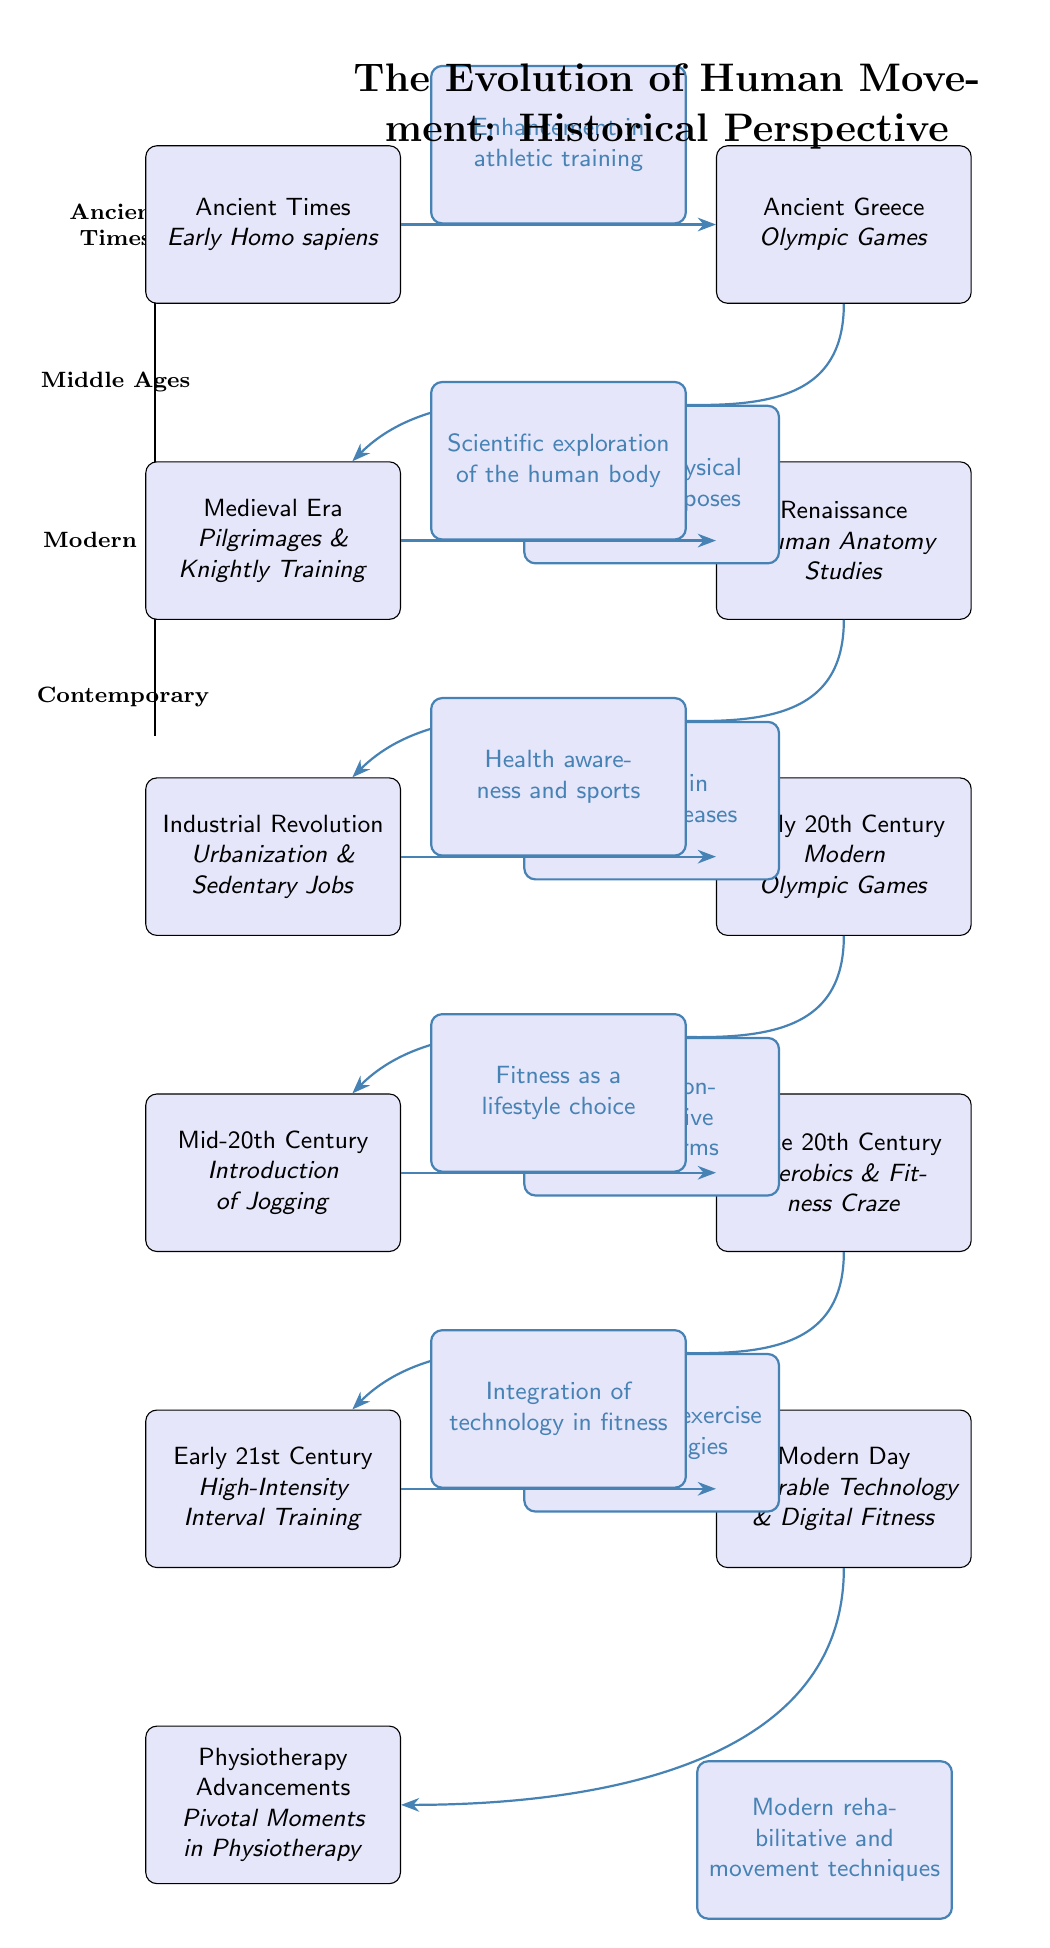What period does the diagram start from? The diagram starts from the "Ancient Times" node located at the top of the timeline. This node represents the earliest period in the evolution of human movement.
Answer: Ancient Times Which ancient cultural event is highlighted on the timeline? The diagram includes "Ancient Greece" with a focus on the "Olympic Games" showcasing the importance of athletic events in that era.
Answer: Olympic Games How many major periods are depicted in the diagram? There are four major periods represented in the diagram: Ancient Times, Middle Ages, Modern Era, and Contemporary, making a total of four periods.
Answer: 4 What advancement is noted in the Mid-20th Century? The Mid-20th Century node highlights the "Introduction of Jogging," which marks a significant shift in physical activity.
Answer: Introduction of Jogging What connection exists between the Renaissance node and the Industrial Revolution node? The "Renaissance" node indicates a direct relationship to the "Industrial Revolution" node, emphasizing the "Increase in lifestyle diseases" as a consequence of changes during that period.
Answer: Increase in lifestyle diseases What type of fitness is mentioned for the Early 21st Century? The diagram notes "High-Intensity Interval Training" as a prominent fitness trend in the Early 21st Century, illustrating the evolution of exercise methodologies.
Answer: High-Intensity Interval Training Which node is directly influenced by "Modern Day"? The "Modern Day" node influences "Physiotherapy Advancements," indicating that current practices and technology affect rehabilitative and movement techniques.
Answer: Physiotherapy Advancements What significant trend does the Late 20th Century node describe? The Late 20th Century node describes the "Aerobics & Fitness Craze," marking an important evolution in public awareness of fitness methods.
Answer: Aerobics & Fitness Craze How does the timeline relate to the development of physiotherapy techniques? The timeline shows a direct correlation from the "Modern Day" node leading into "Physiotherapy Advancements," indicating that advancements in fitness influence physiotherapy practices.
Answer: Integration of technology in fitness 